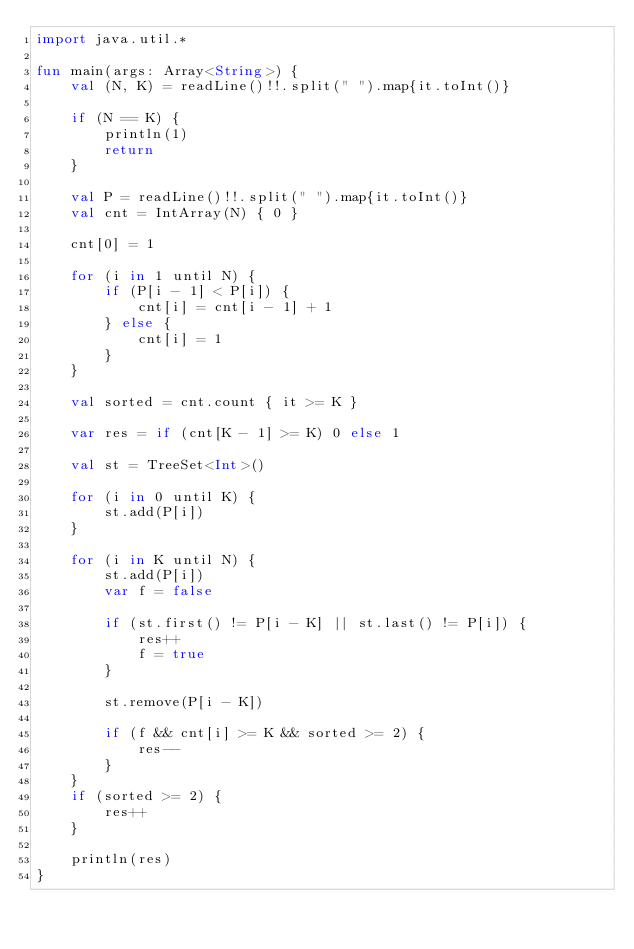Convert code to text. <code><loc_0><loc_0><loc_500><loc_500><_Kotlin_>import java.util.*

fun main(args: Array<String>) {
    val (N, K) = readLine()!!.split(" ").map{it.toInt()}

    if (N == K) {
        println(1)
        return
    }

    val P = readLine()!!.split(" ").map{it.toInt()}
    val cnt = IntArray(N) { 0 }

    cnt[0] = 1

    for (i in 1 until N) {
        if (P[i - 1] < P[i]) {
            cnt[i] = cnt[i - 1] + 1
        } else {
            cnt[i] = 1
        }
    }

    val sorted = cnt.count { it >= K }

    var res = if (cnt[K - 1] >= K) 0 else 1

    val st = TreeSet<Int>()

    for (i in 0 until K) {
        st.add(P[i])
    }

    for (i in K until N) {
        st.add(P[i])
        var f = false

        if (st.first() != P[i - K] || st.last() != P[i]) {
            res++
            f = true
        }

        st.remove(P[i - K])

        if (f && cnt[i] >= K && sorted >= 2) {
            res--
        }
    }
    if (sorted >= 2) {
        res++
    }

    println(res)
}
</code> 